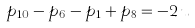Convert formula to latex. <formula><loc_0><loc_0><loc_500><loc_500>p _ { 1 0 } - p _ { 6 } - p _ { 1 } + p _ { 8 } = - 2 \, u</formula> 